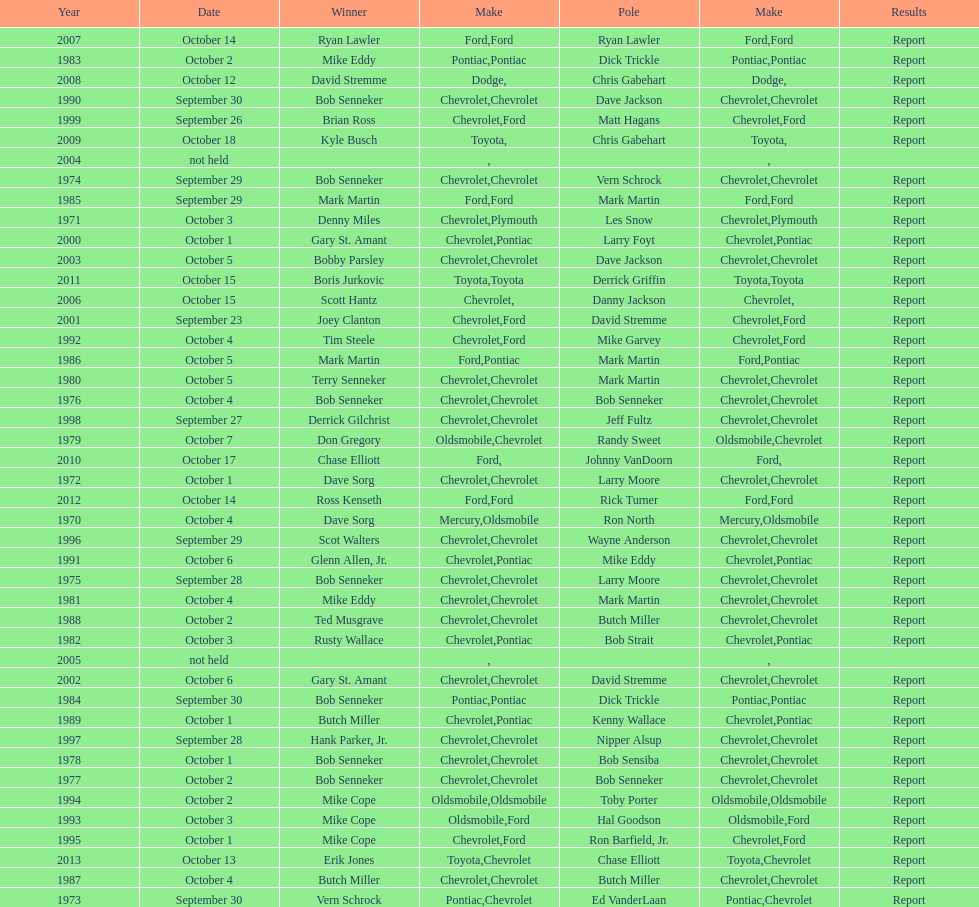Who on the list has the highest number of consecutive wins? Bob Senneker. 